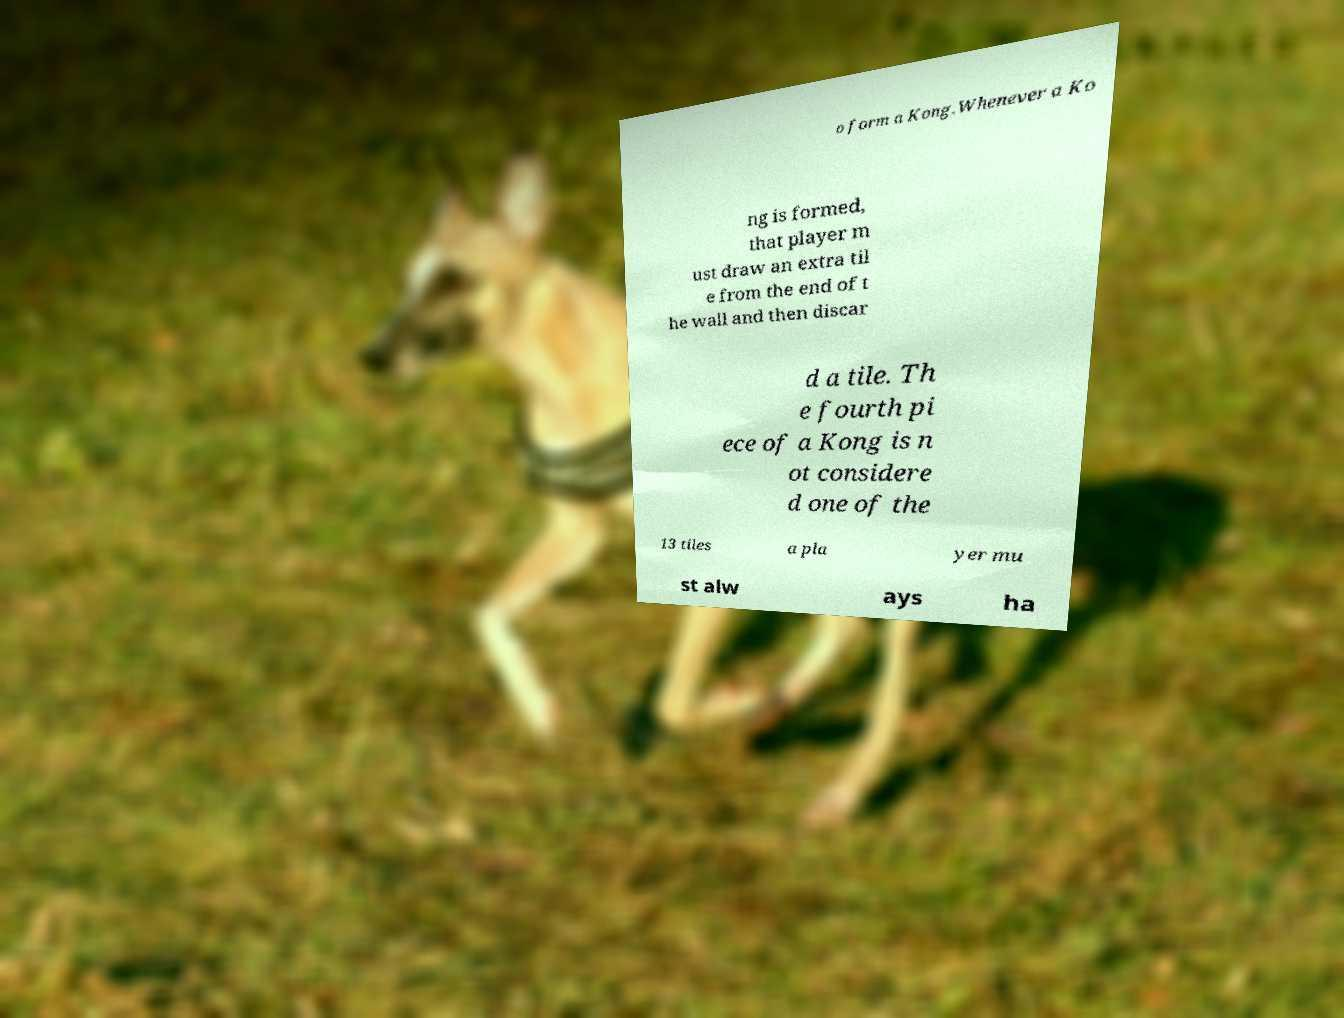There's text embedded in this image that I need extracted. Can you transcribe it verbatim? o form a Kong.Whenever a Ko ng is formed, that player m ust draw an extra til e from the end of t he wall and then discar d a tile. Th e fourth pi ece of a Kong is n ot considere d one of the 13 tiles a pla yer mu st alw ays ha 